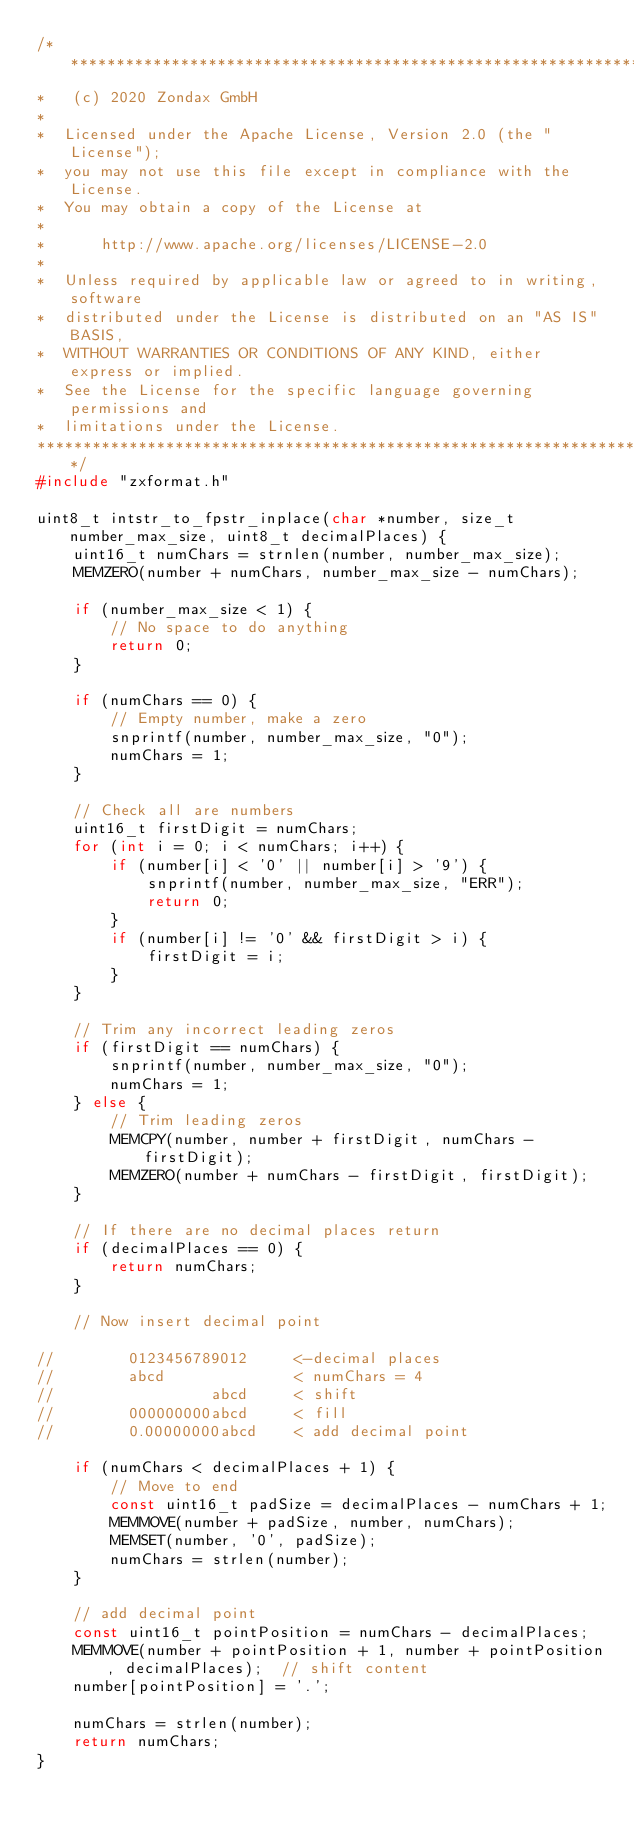<code> <loc_0><loc_0><loc_500><loc_500><_C_>/*******************************************************************************
*   (c) 2020 Zondax GmbH
*
*  Licensed under the Apache License, Version 2.0 (the "License");
*  you may not use this file except in compliance with the License.
*  You may obtain a copy of the License at
*
*      http://www.apache.org/licenses/LICENSE-2.0
*
*  Unless required by applicable law or agreed to in writing, software
*  distributed under the License is distributed on an "AS IS" BASIS,
*  WITHOUT WARRANTIES OR CONDITIONS OF ANY KIND, either express or implied.
*  See the License for the specific language governing permissions and
*  limitations under the License.
********************************************************************************/
#include "zxformat.h"

uint8_t intstr_to_fpstr_inplace(char *number, size_t number_max_size, uint8_t decimalPlaces) {
    uint16_t numChars = strnlen(number, number_max_size);
    MEMZERO(number + numChars, number_max_size - numChars);

    if (number_max_size < 1) {
        // No space to do anything
        return 0;
    }

    if (numChars == 0) {
        // Empty number, make a zero
        snprintf(number, number_max_size, "0");
        numChars = 1;
    }

    // Check all are numbers
    uint16_t firstDigit = numChars;
    for (int i = 0; i < numChars; i++) {
        if (number[i] < '0' || number[i] > '9') {
            snprintf(number, number_max_size, "ERR");
            return 0;
        }
        if (number[i] != '0' && firstDigit > i) {
            firstDigit = i;
        }
    }

    // Trim any incorrect leading zeros
    if (firstDigit == numChars) {
        snprintf(number, number_max_size, "0");
        numChars = 1;
    } else {
        // Trim leading zeros
        MEMCPY(number, number + firstDigit, numChars - firstDigit);
        MEMZERO(number + numChars - firstDigit, firstDigit);
    }

    // If there are no decimal places return
    if (decimalPlaces == 0) {
        return numChars;
    }

    // Now insert decimal point

//        0123456789012     <-decimal places
//        abcd              < numChars = 4
//                 abcd     < shift
//        000000000abcd     < fill
//        0.00000000abcd    < add decimal point

    if (numChars < decimalPlaces + 1) {
        // Move to end
        const uint16_t padSize = decimalPlaces - numChars + 1;
        MEMMOVE(number + padSize, number, numChars);
        MEMSET(number, '0', padSize);
        numChars = strlen(number);
    }

    // add decimal point
    const uint16_t pointPosition = numChars - decimalPlaces;
    MEMMOVE(number + pointPosition + 1, number + pointPosition, decimalPlaces);  // shift content
    number[pointPosition] = '.';

    numChars = strlen(number);
    return numChars;
}
</code> 